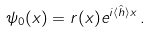<formula> <loc_0><loc_0><loc_500><loc_500>\psi _ { 0 } ( x ) = r ( x ) e ^ { i \langle \hat { h } \rangle x } \, .</formula> 